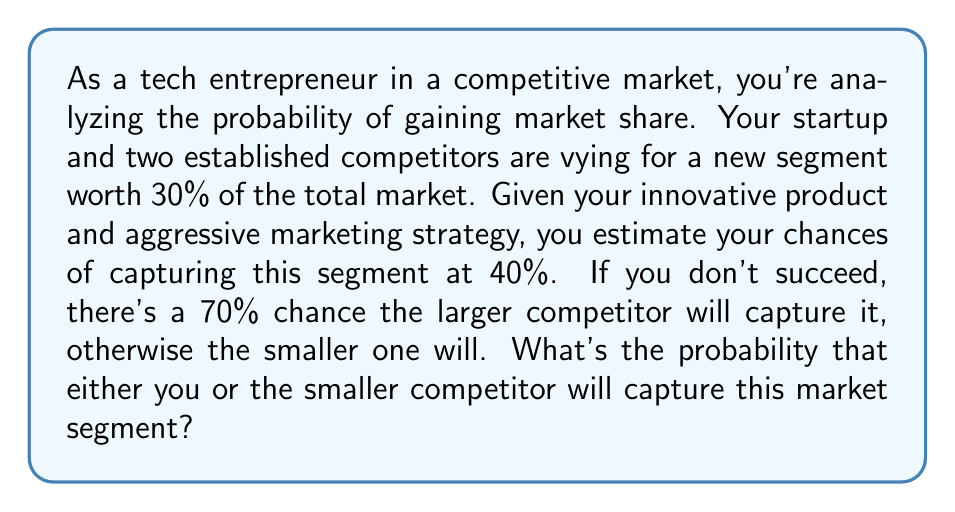What is the answer to this math problem? Let's approach this step-by-step:

1) Let's define events:
   A: Your startup captures the market segment
   B: The larger competitor captures the market segment
   C: The smaller competitor captures the market segment

2) Given probabilities:
   P(A) = 0.40 (40% chance you capture the segment)
   P(B|A') = 0.70 (70% chance the larger competitor captures if you don't)

3) We need to find P(A or C), which is equivalent to 1 - P(B)

4) To find P(B), we use the law of total probability:
   P(B) = P(B|A) * P(A) + P(B|A') * P(A')

5) We know:
   P(B|A) = 0 (if you capture the segment, the larger competitor can't)
   P(A) = 0.40
   P(A') = 1 - P(A) = 0.60
   P(B|A') = 0.70

6) Substituting into the formula:
   P(B) = 0 * 0.40 + 0.70 * 0.60 = 0.42

7) Therefore, the probability that either you or the smaller competitor captures the segment is:
   P(A or C) = 1 - P(B) = 1 - 0.42 = 0.58

Thus, there's a 58% chance that either you or the smaller competitor will capture this market segment.
Answer: 0.58 or 58% 